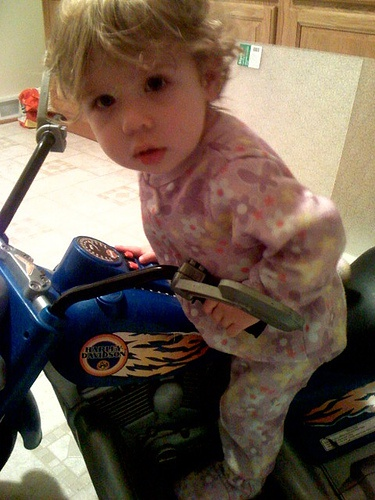Describe the objects in this image and their specific colors. I can see people in darkgray, maroon, brown, and gray tones and motorcycle in darkgray, black, navy, maroon, and gray tones in this image. 